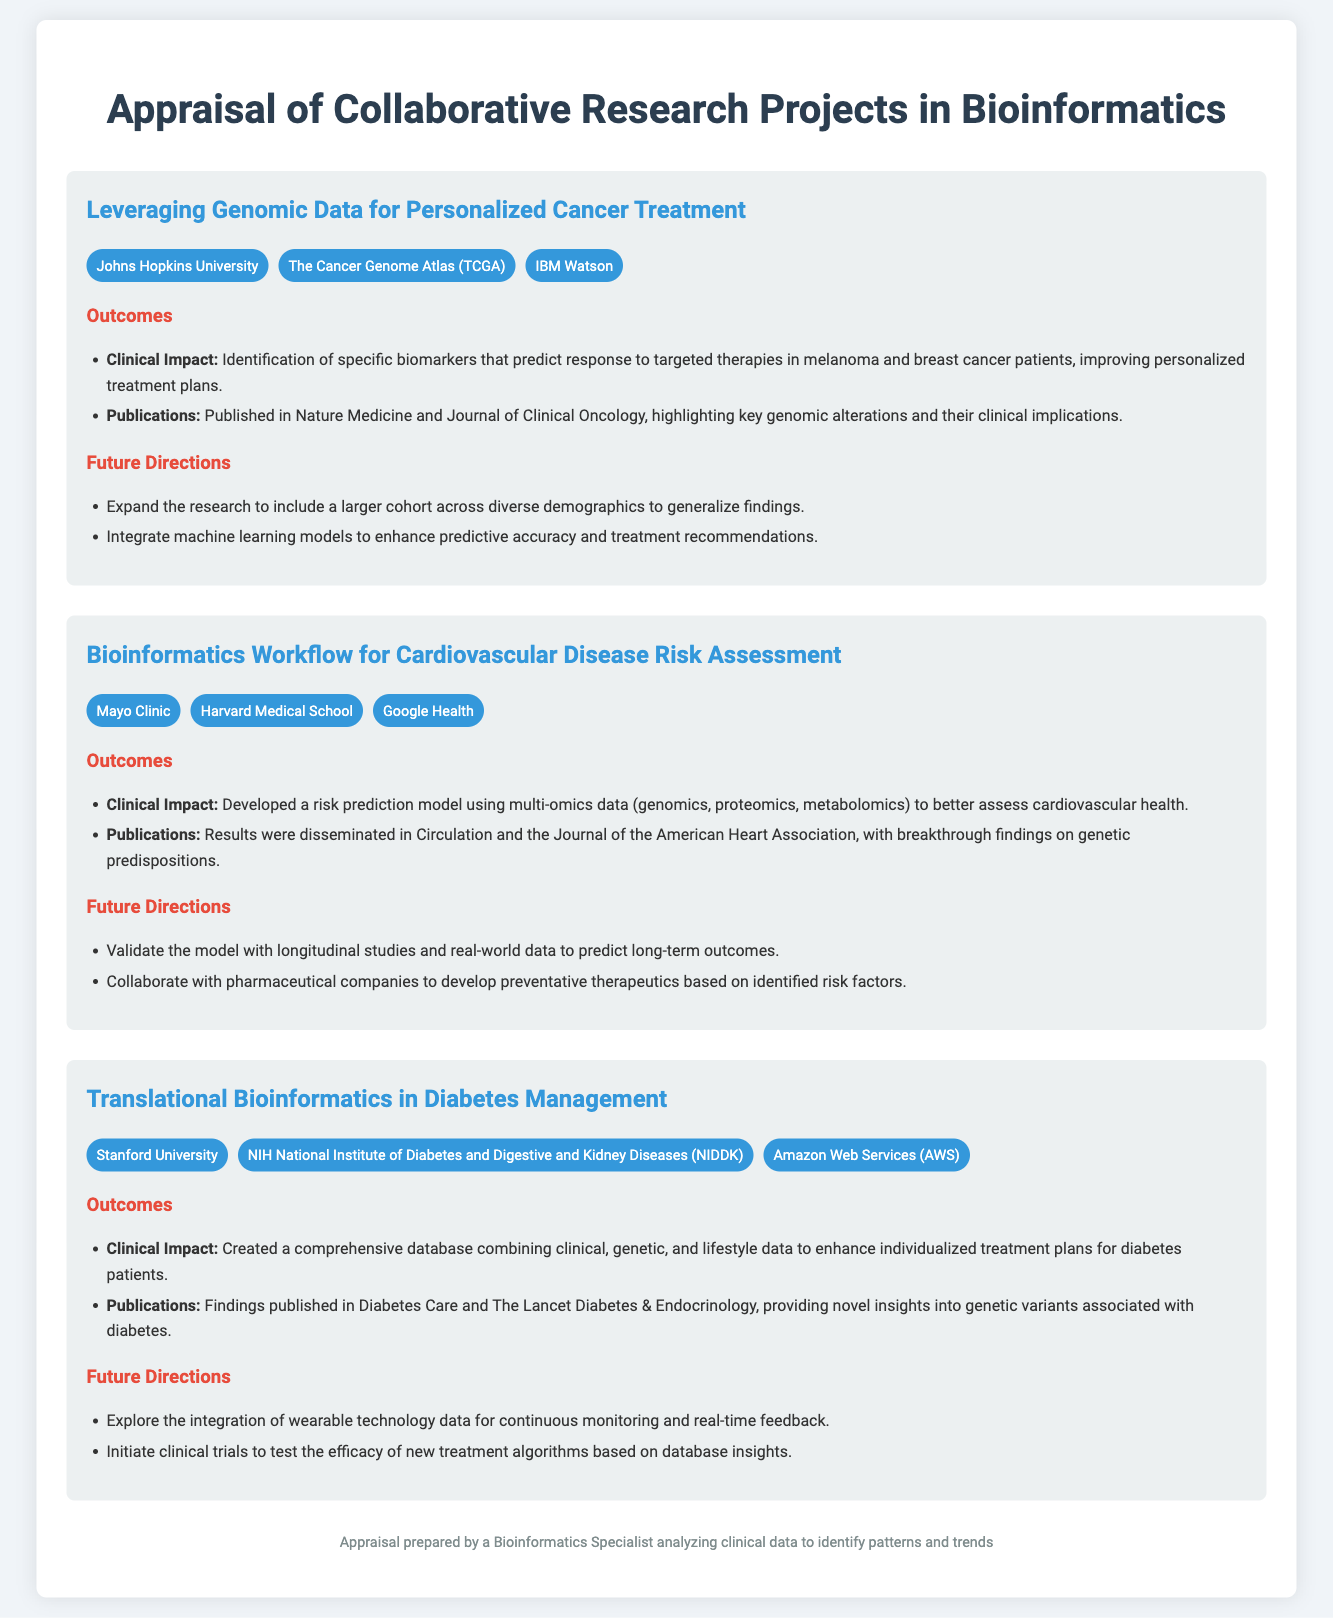What is the title of the first project? The title is listed at the beginning of the first project section in the document.
Answer: Leveraging Genomic Data for Personalized Cancer Treatment Which publication is associated with the second project? The publication is mentioned under the outcomes section for the second project.
Answer: Circulation What are the future directions for the third project? The future directions are outlined in a list under the third project's section in the document.
Answer: Explore the integration of wearable technology data for continuous monitoring and real-time feedback How many collaborators are involved in the project on diabetes management? The number of collaborators can be counted from the list provided under that project.
Answer: Three What type of data did the second project utilize for risk assessment? The type of data is specified in the outcomes section of the second project.
Answer: Multi-omics data What is a clinical impact mentioned in the first project? The clinical impact is described in the outcomes section of the first project.
Answer: Identification of specific biomarkers that predict response to targeted therapies Who collaborated with Stanford University on the diabetes management project? The second collaborator is mentioned in the list of collaborators for the diabetes management project.
Answer: NIH National Institute of Diabetes and Digestive and Kidney Diseases (NIDDK) Which journal published the findings of the first project? The journal names are listed under the outcomes section, specifying where the findings were published.
Answer: Nature Medicine What is the primary goal of the research on cardiovascular disease? The primary goal is discussed under the clinical impact section of the second project.
Answer: Better assess cardiovascular health 